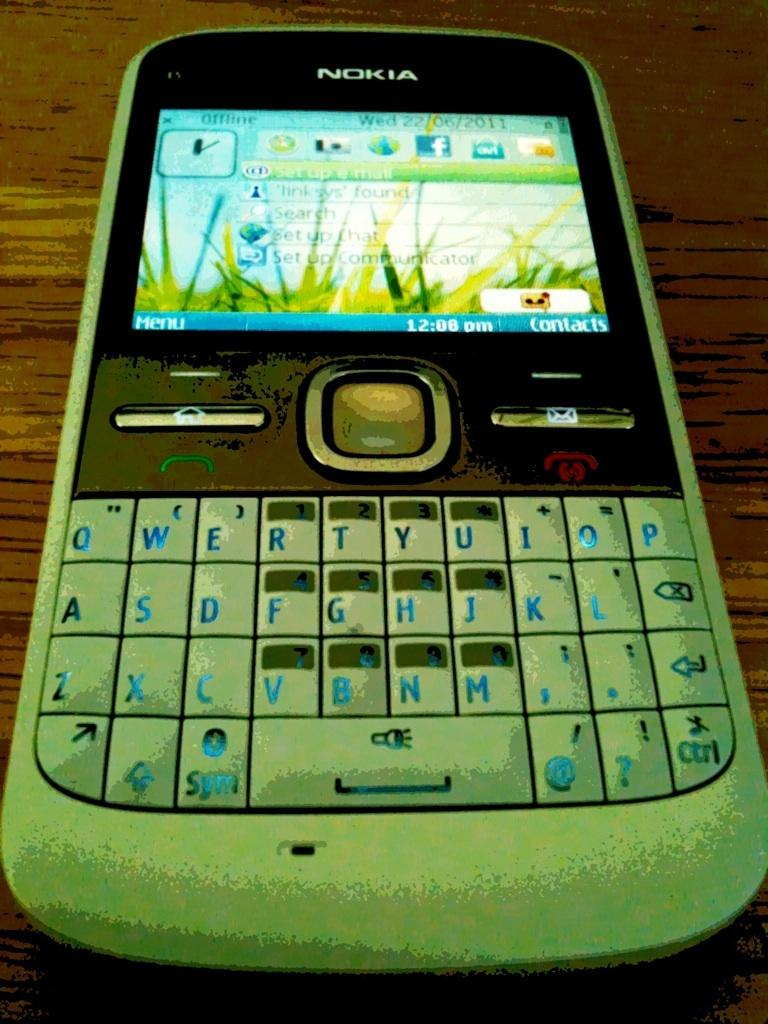Provide a one-sentence caption for the provided image. A cell phone from the brand Nokia is on a wooden surface. 